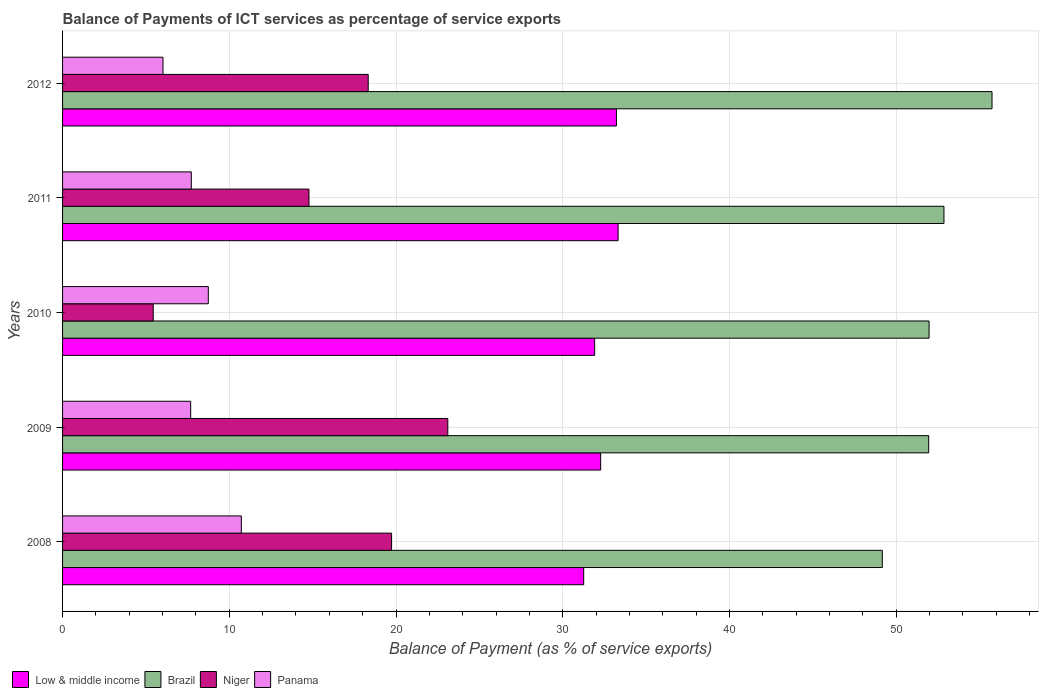How many different coloured bars are there?
Your answer should be very brief. 4. How many groups of bars are there?
Your answer should be compact. 5. Are the number of bars on each tick of the Y-axis equal?
Provide a short and direct response. Yes. What is the label of the 3rd group of bars from the top?
Make the answer very short. 2010. What is the balance of payments of ICT services in Panama in 2010?
Provide a succinct answer. 8.74. Across all years, what is the maximum balance of payments of ICT services in Niger?
Offer a very short reply. 23.11. Across all years, what is the minimum balance of payments of ICT services in Niger?
Your answer should be very brief. 5.44. What is the total balance of payments of ICT services in Panama in the graph?
Your response must be concise. 40.89. What is the difference between the balance of payments of ICT services in Low & middle income in 2008 and that in 2011?
Offer a terse response. -2.06. What is the difference between the balance of payments of ICT services in Low & middle income in 2008 and the balance of payments of ICT services in Brazil in 2012?
Your response must be concise. -24.49. What is the average balance of payments of ICT services in Low & middle income per year?
Your response must be concise. 32.4. In the year 2010, what is the difference between the balance of payments of ICT services in Low & middle income and balance of payments of ICT services in Panama?
Offer a very short reply. 23.17. In how many years, is the balance of payments of ICT services in Panama greater than 16 %?
Your answer should be compact. 0. What is the ratio of the balance of payments of ICT services in Panama in 2009 to that in 2010?
Ensure brevity in your answer.  0.88. Is the balance of payments of ICT services in Brazil in 2008 less than that in 2010?
Offer a very short reply. Yes. Is the difference between the balance of payments of ICT services in Low & middle income in 2008 and 2011 greater than the difference between the balance of payments of ICT services in Panama in 2008 and 2011?
Keep it short and to the point. No. What is the difference between the highest and the second highest balance of payments of ICT services in Brazil?
Ensure brevity in your answer.  2.88. What is the difference between the highest and the lowest balance of payments of ICT services in Niger?
Provide a succinct answer. 17.67. In how many years, is the balance of payments of ICT services in Low & middle income greater than the average balance of payments of ICT services in Low & middle income taken over all years?
Make the answer very short. 2. Is the sum of the balance of payments of ICT services in Niger in 2008 and 2010 greater than the maximum balance of payments of ICT services in Brazil across all years?
Your answer should be compact. No. Is it the case that in every year, the sum of the balance of payments of ICT services in Low & middle income and balance of payments of ICT services in Panama is greater than the sum of balance of payments of ICT services in Niger and balance of payments of ICT services in Brazil?
Ensure brevity in your answer.  Yes. What does the 1st bar from the top in 2008 represents?
Provide a short and direct response. Panama. What does the 2nd bar from the bottom in 2010 represents?
Ensure brevity in your answer.  Brazil. Is it the case that in every year, the sum of the balance of payments of ICT services in Niger and balance of payments of ICT services in Panama is greater than the balance of payments of ICT services in Low & middle income?
Ensure brevity in your answer.  No. Are all the bars in the graph horizontal?
Offer a terse response. Yes. How many years are there in the graph?
Give a very brief answer. 5. Are the values on the major ticks of X-axis written in scientific E-notation?
Your answer should be compact. No. Does the graph contain any zero values?
Your response must be concise. No. Where does the legend appear in the graph?
Keep it short and to the point. Bottom left. What is the title of the graph?
Ensure brevity in your answer.  Balance of Payments of ICT services as percentage of service exports. Does "Puerto Rico" appear as one of the legend labels in the graph?
Offer a terse response. No. What is the label or title of the X-axis?
Your response must be concise. Balance of Payment (as % of service exports). What is the Balance of Payment (as % of service exports) of Low & middle income in 2008?
Offer a terse response. 31.26. What is the Balance of Payment (as % of service exports) of Brazil in 2008?
Provide a succinct answer. 49.17. What is the Balance of Payment (as % of service exports) in Niger in 2008?
Your answer should be compact. 19.73. What is the Balance of Payment (as % of service exports) of Panama in 2008?
Offer a very short reply. 10.72. What is the Balance of Payment (as % of service exports) in Low & middle income in 2009?
Your answer should be very brief. 32.27. What is the Balance of Payment (as % of service exports) of Brazil in 2009?
Your answer should be very brief. 51.95. What is the Balance of Payment (as % of service exports) in Niger in 2009?
Provide a succinct answer. 23.11. What is the Balance of Payment (as % of service exports) in Panama in 2009?
Make the answer very short. 7.68. What is the Balance of Payment (as % of service exports) of Low & middle income in 2010?
Your answer should be compact. 31.91. What is the Balance of Payment (as % of service exports) in Brazil in 2010?
Offer a very short reply. 51.97. What is the Balance of Payment (as % of service exports) of Niger in 2010?
Ensure brevity in your answer.  5.44. What is the Balance of Payment (as % of service exports) in Panama in 2010?
Offer a very short reply. 8.74. What is the Balance of Payment (as % of service exports) of Low & middle income in 2011?
Your answer should be compact. 33.32. What is the Balance of Payment (as % of service exports) of Brazil in 2011?
Provide a succinct answer. 52.86. What is the Balance of Payment (as % of service exports) in Niger in 2011?
Give a very brief answer. 14.78. What is the Balance of Payment (as % of service exports) of Panama in 2011?
Provide a short and direct response. 7.72. What is the Balance of Payment (as % of service exports) of Low & middle income in 2012?
Provide a succinct answer. 33.22. What is the Balance of Payment (as % of service exports) of Brazil in 2012?
Ensure brevity in your answer.  55.75. What is the Balance of Payment (as % of service exports) in Niger in 2012?
Offer a very short reply. 18.33. What is the Balance of Payment (as % of service exports) in Panama in 2012?
Offer a terse response. 6.02. Across all years, what is the maximum Balance of Payment (as % of service exports) in Low & middle income?
Your answer should be very brief. 33.32. Across all years, what is the maximum Balance of Payment (as % of service exports) in Brazil?
Provide a short and direct response. 55.75. Across all years, what is the maximum Balance of Payment (as % of service exports) of Niger?
Your response must be concise. 23.11. Across all years, what is the maximum Balance of Payment (as % of service exports) of Panama?
Provide a short and direct response. 10.72. Across all years, what is the minimum Balance of Payment (as % of service exports) in Low & middle income?
Make the answer very short. 31.26. Across all years, what is the minimum Balance of Payment (as % of service exports) of Brazil?
Your response must be concise. 49.17. Across all years, what is the minimum Balance of Payment (as % of service exports) of Niger?
Provide a short and direct response. 5.44. Across all years, what is the minimum Balance of Payment (as % of service exports) of Panama?
Offer a very short reply. 6.02. What is the total Balance of Payment (as % of service exports) in Low & middle income in the graph?
Your answer should be compact. 161.98. What is the total Balance of Payment (as % of service exports) in Brazil in the graph?
Keep it short and to the point. 261.7. What is the total Balance of Payment (as % of service exports) in Niger in the graph?
Offer a terse response. 81.39. What is the total Balance of Payment (as % of service exports) of Panama in the graph?
Provide a succinct answer. 40.89. What is the difference between the Balance of Payment (as % of service exports) of Low & middle income in 2008 and that in 2009?
Your answer should be compact. -1.02. What is the difference between the Balance of Payment (as % of service exports) in Brazil in 2008 and that in 2009?
Offer a very short reply. -2.78. What is the difference between the Balance of Payment (as % of service exports) in Niger in 2008 and that in 2009?
Keep it short and to the point. -3.37. What is the difference between the Balance of Payment (as % of service exports) in Panama in 2008 and that in 2009?
Your answer should be very brief. 3.04. What is the difference between the Balance of Payment (as % of service exports) in Low & middle income in 2008 and that in 2010?
Your answer should be compact. -0.66. What is the difference between the Balance of Payment (as % of service exports) in Brazil in 2008 and that in 2010?
Provide a succinct answer. -2.81. What is the difference between the Balance of Payment (as % of service exports) of Niger in 2008 and that in 2010?
Provide a short and direct response. 14.3. What is the difference between the Balance of Payment (as % of service exports) of Panama in 2008 and that in 2010?
Your answer should be very brief. 1.98. What is the difference between the Balance of Payment (as % of service exports) of Low & middle income in 2008 and that in 2011?
Keep it short and to the point. -2.06. What is the difference between the Balance of Payment (as % of service exports) of Brazil in 2008 and that in 2011?
Provide a short and direct response. -3.7. What is the difference between the Balance of Payment (as % of service exports) in Niger in 2008 and that in 2011?
Offer a terse response. 4.95. What is the difference between the Balance of Payment (as % of service exports) in Panama in 2008 and that in 2011?
Your answer should be very brief. 3. What is the difference between the Balance of Payment (as % of service exports) in Low & middle income in 2008 and that in 2012?
Keep it short and to the point. -1.96. What is the difference between the Balance of Payment (as % of service exports) of Brazil in 2008 and that in 2012?
Offer a terse response. -6.58. What is the difference between the Balance of Payment (as % of service exports) in Niger in 2008 and that in 2012?
Your answer should be compact. 1.4. What is the difference between the Balance of Payment (as % of service exports) in Panama in 2008 and that in 2012?
Your response must be concise. 4.7. What is the difference between the Balance of Payment (as % of service exports) of Low & middle income in 2009 and that in 2010?
Keep it short and to the point. 0.36. What is the difference between the Balance of Payment (as % of service exports) of Brazil in 2009 and that in 2010?
Provide a short and direct response. -0.02. What is the difference between the Balance of Payment (as % of service exports) in Niger in 2009 and that in 2010?
Your answer should be very brief. 17.67. What is the difference between the Balance of Payment (as % of service exports) of Panama in 2009 and that in 2010?
Ensure brevity in your answer.  -1.06. What is the difference between the Balance of Payment (as % of service exports) in Low & middle income in 2009 and that in 2011?
Your answer should be very brief. -1.05. What is the difference between the Balance of Payment (as % of service exports) of Brazil in 2009 and that in 2011?
Offer a terse response. -0.92. What is the difference between the Balance of Payment (as % of service exports) in Niger in 2009 and that in 2011?
Keep it short and to the point. 8.33. What is the difference between the Balance of Payment (as % of service exports) in Panama in 2009 and that in 2011?
Keep it short and to the point. -0.04. What is the difference between the Balance of Payment (as % of service exports) in Low & middle income in 2009 and that in 2012?
Provide a succinct answer. -0.95. What is the difference between the Balance of Payment (as % of service exports) of Brazil in 2009 and that in 2012?
Your response must be concise. -3.8. What is the difference between the Balance of Payment (as % of service exports) of Niger in 2009 and that in 2012?
Make the answer very short. 4.78. What is the difference between the Balance of Payment (as % of service exports) of Panama in 2009 and that in 2012?
Your answer should be very brief. 1.66. What is the difference between the Balance of Payment (as % of service exports) of Low & middle income in 2010 and that in 2011?
Keep it short and to the point. -1.41. What is the difference between the Balance of Payment (as % of service exports) in Brazil in 2010 and that in 2011?
Keep it short and to the point. -0.89. What is the difference between the Balance of Payment (as % of service exports) of Niger in 2010 and that in 2011?
Provide a succinct answer. -9.34. What is the difference between the Balance of Payment (as % of service exports) of Panama in 2010 and that in 2011?
Give a very brief answer. 1.02. What is the difference between the Balance of Payment (as % of service exports) of Low & middle income in 2010 and that in 2012?
Keep it short and to the point. -1.31. What is the difference between the Balance of Payment (as % of service exports) of Brazil in 2010 and that in 2012?
Provide a succinct answer. -3.77. What is the difference between the Balance of Payment (as % of service exports) of Niger in 2010 and that in 2012?
Offer a terse response. -12.89. What is the difference between the Balance of Payment (as % of service exports) in Panama in 2010 and that in 2012?
Keep it short and to the point. 2.72. What is the difference between the Balance of Payment (as % of service exports) of Low & middle income in 2011 and that in 2012?
Your answer should be compact. 0.1. What is the difference between the Balance of Payment (as % of service exports) in Brazil in 2011 and that in 2012?
Give a very brief answer. -2.88. What is the difference between the Balance of Payment (as % of service exports) in Niger in 2011 and that in 2012?
Offer a terse response. -3.55. What is the difference between the Balance of Payment (as % of service exports) in Panama in 2011 and that in 2012?
Your response must be concise. 1.7. What is the difference between the Balance of Payment (as % of service exports) in Low & middle income in 2008 and the Balance of Payment (as % of service exports) in Brazil in 2009?
Your response must be concise. -20.69. What is the difference between the Balance of Payment (as % of service exports) of Low & middle income in 2008 and the Balance of Payment (as % of service exports) of Niger in 2009?
Ensure brevity in your answer.  8.15. What is the difference between the Balance of Payment (as % of service exports) of Low & middle income in 2008 and the Balance of Payment (as % of service exports) of Panama in 2009?
Provide a succinct answer. 23.57. What is the difference between the Balance of Payment (as % of service exports) of Brazil in 2008 and the Balance of Payment (as % of service exports) of Niger in 2009?
Offer a very short reply. 26.06. What is the difference between the Balance of Payment (as % of service exports) in Brazil in 2008 and the Balance of Payment (as % of service exports) in Panama in 2009?
Provide a short and direct response. 41.48. What is the difference between the Balance of Payment (as % of service exports) in Niger in 2008 and the Balance of Payment (as % of service exports) in Panama in 2009?
Your answer should be very brief. 12.05. What is the difference between the Balance of Payment (as % of service exports) of Low & middle income in 2008 and the Balance of Payment (as % of service exports) of Brazil in 2010?
Your response must be concise. -20.72. What is the difference between the Balance of Payment (as % of service exports) in Low & middle income in 2008 and the Balance of Payment (as % of service exports) in Niger in 2010?
Your answer should be compact. 25.82. What is the difference between the Balance of Payment (as % of service exports) in Low & middle income in 2008 and the Balance of Payment (as % of service exports) in Panama in 2010?
Provide a succinct answer. 22.51. What is the difference between the Balance of Payment (as % of service exports) in Brazil in 2008 and the Balance of Payment (as % of service exports) in Niger in 2010?
Provide a succinct answer. 43.73. What is the difference between the Balance of Payment (as % of service exports) in Brazil in 2008 and the Balance of Payment (as % of service exports) in Panama in 2010?
Your response must be concise. 40.43. What is the difference between the Balance of Payment (as % of service exports) in Niger in 2008 and the Balance of Payment (as % of service exports) in Panama in 2010?
Provide a short and direct response. 10.99. What is the difference between the Balance of Payment (as % of service exports) in Low & middle income in 2008 and the Balance of Payment (as % of service exports) in Brazil in 2011?
Make the answer very short. -21.61. What is the difference between the Balance of Payment (as % of service exports) in Low & middle income in 2008 and the Balance of Payment (as % of service exports) in Niger in 2011?
Give a very brief answer. 16.48. What is the difference between the Balance of Payment (as % of service exports) in Low & middle income in 2008 and the Balance of Payment (as % of service exports) in Panama in 2011?
Offer a terse response. 23.53. What is the difference between the Balance of Payment (as % of service exports) of Brazil in 2008 and the Balance of Payment (as % of service exports) of Niger in 2011?
Ensure brevity in your answer.  34.39. What is the difference between the Balance of Payment (as % of service exports) in Brazil in 2008 and the Balance of Payment (as % of service exports) in Panama in 2011?
Provide a short and direct response. 41.45. What is the difference between the Balance of Payment (as % of service exports) in Niger in 2008 and the Balance of Payment (as % of service exports) in Panama in 2011?
Offer a terse response. 12.01. What is the difference between the Balance of Payment (as % of service exports) of Low & middle income in 2008 and the Balance of Payment (as % of service exports) of Brazil in 2012?
Your response must be concise. -24.49. What is the difference between the Balance of Payment (as % of service exports) of Low & middle income in 2008 and the Balance of Payment (as % of service exports) of Niger in 2012?
Offer a very short reply. 12.92. What is the difference between the Balance of Payment (as % of service exports) of Low & middle income in 2008 and the Balance of Payment (as % of service exports) of Panama in 2012?
Keep it short and to the point. 25.23. What is the difference between the Balance of Payment (as % of service exports) of Brazil in 2008 and the Balance of Payment (as % of service exports) of Niger in 2012?
Offer a terse response. 30.84. What is the difference between the Balance of Payment (as % of service exports) of Brazil in 2008 and the Balance of Payment (as % of service exports) of Panama in 2012?
Provide a short and direct response. 43.14. What is the difference between the Balance of Payment (as % of service exports) of Niger in 2008 and the Balance of Payment (as % of service exports) of Panama in 2012?
Your answer should be compact. 13.71. What is the difference between the Balance of Payment (as % of service exports) of Low & middle income in 2009 and the Balance of Payment (as % of service exports) of Brazil in 2010?
Give a very brief answer. -19.7. What is the difference between the Balance of Payment (as % of service exports) in Low & middle income in 2009 and the Balance of Payment (as % of service exports) in Niger in 2010?
Ensure brevity in your answer.  26.84. What is the difference between the Balance of Payment (as % of service exports) of Low & middle income in 2009 and the Balance of Payment (as % of service exports) of Panama in 2010?
Keep it short and to the point. 23.53. What is the difference between the Balance of Payment (as % of service exports) in Brazil in 2009 and the Balance of Payment (as % of service exports) in Niger in 2010?
Your response must be concise. 46.51. What is the difference between the Balance of Payment (as % of service exports) in Brazil in 2009 and the Balance of Payment (as % of service exports) in Panama in 2010?
Ensure brevity in your answer.  43.21. What is the difference between the Balance of Payment (as % of service exports) in Niger in 2009 and the Balance of Payment (as % of service exports) in Panama in 2010?
Ensure brevity in your answer.  14.36. What is the difference between the Balance of Payment (as % of service exports) of Low & middle income in 2009 and the Balance of Payment (as % of service exports) of Brazil in 2011?
Offer a terse response. -20.59. What is the difference between the Balance of Payment (as % of service exports) of Low & middle income in 2009 and the Balance of Payment (as % of service exports) of Niger in 2011?
Make the answer very short. 17.49. What is the difference between the Balance of Payment (as % of service exports) of Low & middle income in 2009 and the Balance of Payment (as % of service exports) of Panama in 2011?
Offer a terse response. 24.55. What is the difference between the Balance of Payment (as % of service exports) in Brazil in 2009 and the Balance of Payment (as % of service exports) in Niger in 2011?
Your response must be concise. 37.17. What is the difference between the Balance of Payment (as % of service exports) of Brazil in 2009 and the Balance of Payment (as % of service exports) of Panama in 2011?
Give a very brief answer. 44.23. What is the difference between the Balance of Payment (as % of service exports) in Niger in 2009 and the Balance of Payment (as % of service exports) in Panama in 2011?
Make the answer very short. 15.38. What is the difference between the Balance of Payment (as % of service exports) of Low & middle income in 2009 and the Balance of Payment (as % of service exports) of Brazil in 2012?
Ensure brevity in your answer.  -23.47. What is the difference between the Balance of Payment (as % of service exports) in Low & middle income in 2009 and the Balance of Payment (as % of service exports) in Niger in 2012?
Ensure brevity in your answer.  13.94. What is the difference between the Balance of Payment (as % of service exports) of Low & middle income in 2009 and the Balance of Payment (as % of service exports) of Panama in 2012?
Your response must be concise. 26.25. What is the difference between the Balance of Payment (as % of service exports) in Brazil in 2009 and the Balance of Payment (as % of service exports) in Niger in 2012?
Make the answer very short. 33.62. What is the difference between the Balance of Payment (as % of service exports) of Brazil in 2009 and the Balance of Payment (as % of service exports) of Panama in 2012?
Ensure brevity in your answer.  45.93. What is the difference between the Balance of Payment (as % of service exports) in Niger in 2009 and the Balance of Payment (as % of service exports) in Panama in 2012?
Provide a short and direct response. 17.08. What is the difference between the Balance of Payment (as % of service exports) of Low & middle income in 2010 and the Balance of Payment (as % of service exports) of Brazil in 2011?
Offer a very short reply. -20.95. What is the difference between the Balance of Payment (as % of service exports) of Low & middle income in 2010 and the Balance of Payment (as % of service exports) of Niger in 2011?
Offer a very short reply. 17.13. What is the difference between the Balance of Payment (as % of service exports) in Low & middle income in 2010 and the Balance of Payment (as % of service exports) in Panama in 2011?
Give a very brief answer. 24.19. What is the difference between the Balance of Payment (as % of service exports) of Brazil in 2010 and the Balance of Payment (as % of service exports) of Niger in 2011?
Your answer should be compact. 37.19. What is the difference between the Balance of Payment (as % of service exports) of Brazil in 2010 and the Balance of Payment (as % of service exports) of Panama in 2011?
Offer a terse response. 44.25. What is the difference between the Balance of Payment (as % of service exports) of Niger in 2010 and the Balance of Payment (as % of service exports) of Panama in 2011?
Offer a very short reply. -2.28. What is the difference between the Balance of Payment (as % of service exports) of Low & middle income in 2010 and the Balance of Payment (as % of service exports) of Brazil in 2012?
Provide a succinct answer. -23.83. What is the difference between the Balance of Payment (as % of service exports) of Low & middle income in 2010 and the Balance of Payment (as % of service exports) of Niger in 2012?
Provide a succinct answer. 13.58. What is the difference between the Balance of Payment (as % of service exports) in Low & middle income in 2010 and the Balance of Payment (as % of service exports) in Panama in 2012?
Give a very brief answer. 25.89. What is the difference between the Balance of Payment (as % of service exports) of Brazil in 2010 and the Balance of Payment (as % of service exports) of Niger in 2012?
Offer a very short reply. 33.64. What is the difference between the Balance of Payment (as % of service exports) in Brazil in 2010 and the Balance of Payment (as % of service exports) in Panama in 2012?
Give a very brief answer. 45.95. What is the difference between the Balance of Payment (as % of service exports) of Niger in 2010 and the Balance of Payment (as % of service exports) of Panama in 2012?
Provide a succinct answer. -0.59. What is the difference between the Balance of Payment (as % of service exports) of Low & middle income in 2011 and the Balance of Payment (as % of service exports) of Brazil in 2012?
Offer a terse response. -22.43. What is the difference between the Balance of Payment (as % of service exports) of Low & middle income in 2011 and the Balance of Payment (as % of service exports) of Niger in 2012?
Provide a succinct answer. 14.99. What is the difference between the Balance of Payment (as % of service exports) of Low & middle income in 2011 and the Balance of Payment (as % of service exports) of Panama in 2012?
Make the answer very short. 27.3. What is the difference between the Balance of Payment (as % of service exports) of Brazil in 2011 and the Balance of Payment (as % of service exports) of Niger in 2012?
Provide a succinct answer. 34.53. What is the difference between the Balance of Payment (as % of service exports) of Brazil in 2011 and the Balance of Payment (as % of service exports) of Panama in 2012?
Keep it short and to the point. 46.84. What is the difference between the Balance of Payment (as % of service exports) of Niger in 2011 and the Balance of Payment (as % of service exports) of Panama in 2012?
Ensure brevity in your answer.  8.76. What is the average Balance of Payment (as % of service exports) of Low & middle income per year?
Offer a very short reply. 32.4. What is the average Balance of Payment (as % of service exports) of Brazil per year?
Provide a succinct answer. 52.34. What is the average Balance of Payment (as % of service exports) of Niger per year?
Your response must be concise. 16.28. What is the average Balance of Payment (as % of service exports) in Panama per year?
Your answer should be compact. 8.18. In the year 2008, what is the difference between the Balance of Payment (as % of service exports) in Low & middle income and Balance of Payment (as % of service exports) in Brazil?
Offer a very short reply. -17.91. In the year 2008, what is the difference between the Balance of Payment (as % of service exports) in Low & middle income and Balance of Payment (as % of service exports) in Niger?
Make the answer very short. 11.52. In the year 2008, what is the difference between the Balance of Payment (as % of service exports) in Low & middle income and Balance of Payment (as % of service exports) in Panama?
Your answer should be compact. 20.53. In the year 2008, what is the difference between the Balance of Payment (as % of service exports) in Brazil and Balance of Payment (as % of service exports) in Niger?
Keep it short and to the point. 29.43. In the year 2008, what is the difference between the Balance of Payment (as % of service exports) in Brazil and Balance of Payment (as % of service exports) in Panama?
Ensure brevity in your answer.  38.44. In the year 2008, what is the difference between the Balance of Payment (as % of service exports) of Niger and Balance of Payment (as % of service exports) of Panama?
Provide a short and direct response. 9.01. In the year 2009, what is the difference between the Balance of Payment (as % of service exports) in Low & middle income and Balance of Payment (as % of service exports) in Brazil?
Offer a very short reply. -19.68. In the year 2009, what is the difference between the Balance of Payment (as % of service exports) in Low & middle income and Balance of Payment (as % of service exports) in Niger?
Provide a succinct answer. 9.17. In the year 2009, what is the difference between the Balance of Payment (as % of service exports) of Low & middle income and Balance of Payment (as % of service exports) of Panama?
Your response must be concise. 24.59. In the year 2009, what is the difference between the Balance of Payment (as % of service exports) of Brazil and Balance of Payment (as % of service exports) of Niger?
Keep it short and to the point. 28.84. In the year 2009, what is the difference between the Balance of Payment (as % of service exports) in Brazil and Balance of Payment (as % of service exports) in Panama?
Offer a very short reply. 44.27. In the year 2009, what is the difference between the Balance of Payment (as % of service exports) in Niger and Balance of Payment (as % of service exports) in Panama?
Give a very brief answer. 15.42. In the year 2010, what is the difference between the Balance of Payment (as % of service exports) of Low & middle income and Balance of Payment (as % of service exports) of Brazil?
Offer a very short reply. -20.06. In the year 2010, what is the difference between the Balance of Payment (as % of service exports) of Low & middle income and Balance of Payment (as % of service exports) of Niger?
Make the answer very short. 26.47. In the year 2010, what is the difference between the Balance of Payment (as % of service exports) of Low & middle income and Balance of Payment (as % of service exports) of Panama?
Offer a terse response. 23.17. In the year 2010, what is the difference between the Balance of Payment (as % of service exports) of Brazil and Balance of Payment (as % of service exports) of Niger?
Provide a short and direct response. 46.53. In the year 2010, what is the difference between the Balance of Payment (as % of service exports) in Brazil and Balance of Payment (as % of service exports) in Panama?
Give a very brief answer. 43.23. In the year 2010, what is the difference between the Balance of Payment (as % of service exports) of Niger and Balance of Payment (as % of service exports) of Panama?
Provide a short and direct response. -3.3. In the year 2011, what is the difference between the Balance of Payment (as % of service exports) of Low & middle income and Balance of Payment (as % of service exports) of Brazil?
Give a very brief answer. -19.54. In the year 2011, what is the difference between the Balance of Payment (as % of service exports) in Low & middle income and Balance of Payment (as % of service exports) in Niger?
Your answer should be very brief. 18.54. In the year 2011, what is the difference between the Balance of Payment (as % of service exports) of Low & middle income and Balance of Payment (as % of service exports) of Panama?
Ensure brevity in your answer.  25.6. In the year 2011, what is the difference between the Balance of Payment (as % of service exports) in Brazil and Balance of Payment (as % of service exports) in Niger?
Offer a very short reply. 38.09. In the year 2011, what is the difference between the Balance of Payment (as % of service exports) in Brazil and Balance of Payment (as % of service exports) in Panama?
Ensure brevity in your answer.  45.14. In the year 2011, what is the difference between the Balance of Payment (as % of service exports) in Niger and Balance of Payment (as % of service exports) in Panama?
Your answer should be very brief. 7.06. In the year 2012, what is the difference between the Balance of Payment (as % of service exports) of Low & middle income and Balance of Payment (as % of service exports) of Brazil?
Make the answer very short. -22.53. In the year 2012, what is the difference between the Balance of Payment (as % of service exports) of Low & middle income and Balance of Payment (as % of service exports) of Niger?
Ensure brevity in your answer.  14.89. In the year 2012, what is the difference between the Balance of Payment (as % of service exports) in Low & middle income and Balance of Payment (as % of service exports) in Panama?
Give a very brief answer. 27.2. In the year 2012, what is the difference between the Balance of Payment (as % of service exports) in Brazil and Balance of Payment (as % of service exports) in Niger?
Offer a terse response. 37.42. In the year 2012, what is the difference between the Balance of Payment (as % of service exports) of Brazil and Balance of Payment (as % of service exports) of Panama?
Provide a succinct answer. 49.72. In the year 2012, what is the difference between the Balance of Payment (as % of service exports) in Niger and Balance of Payment (as % of service exports) in Panama?
Ensure brevity in your answer.  12.31. What is the ratio of the Balance of Payment (as % of service exports) of Low & middle income in 2008 to that in 2009?
Keep it short and to the point. 0.97. What is the ratio of the Balance of Payment (as % of service exports) in Brazil in 2008 to that in 2009?
Offer a terse response. 0.95. What is the ratio of the Balance of Payment (as % of service exports) of Niger in 2008 to that in 2009?
Keep it short and to the point. 0.85. What is the ratio of the Balance of Payment (as % of service exports) of Panama in 2008 to that in 2009?
Ensure brevity in your answer.  1.4. What is the ratio of the Balance of Payment (as % of service exports) in Low & middle income in 2008 to that in 2010?
Ensure brevity in your answer.  0.98. What is the ratio of the Balance of Payment (as % of service exports) in Brazil in 2008 to that in 2010?
Your answer should be compact. 0.95. What is the ratio of the Balance of Payment (as % of service exports) of Niger in 2008 to that in 2010?
Offer a very short reply. 3.63. What is the ratio of the Balance of Payment (as % of service exports) in Panama in 2008 to that in 2010?
Ensure brevity in your answer.  1.23. What is the ratio of the Balance of Payment (as % of service exports) of Low & middle income in 2008 to that in 2011?
Your answer should be compact. 0.94. What is the ratio of the Balance of Payment (as % of service exports) of Brazil in 2008 to that in 2011?
Your answer should be very brief. 0.93. What is the ratio of the Balance of Payment (as % of service exports) of Niger in 2008 to that in 2011?
Make the answer very short. 1.34. What is the ratio of the Balance of Payment (as % of service exports) of Panama in 2008 to that in 2011?
Provide a short and direct response. 1.39. What is the ratio of the Balance of Payment (as % of service exports) in Low & middle income in 2008 to that in 2012?
Offer a terse response. 0.94. What is the ratio of the Balance of Payment (as % of service exports) in Brazil in 2008 to that in 2012?
Offer a terse response. 0.88. What is the ratio of the Balance of Payment (as % of service exports) in Niger in 2008 to that in 2012?
Provide a short and direct response. 1.08. What is the ratio of the Balance of Payment (as % of service exports) in Panama in 2008 to that in 2012?
Your answer should be very brief. 1.78. What is the ratio of the Balance of Payment (as % of service exports) in Low & middle income in 2009 to that in 2010?
Provide a short and direct response. 1.01. What is the ratio of the Balance of Payment (as % of service exports) in Niger in 2009 to that in 2010?
Offer a very short reply. 4.25. What is the ratio of the Balance of Payment (as % of service exports) of Panama in 2009 to that in 2010?
Your response must be concise. 0.88. What is the ratio of the Balance of Payment (as % of service exports) in Low & middle income in 2009 to that in 2011?
Keep it short and to the point. 0.97. What is the ratio of the Balance of Payment (as % of service exports) in Brazil in 2009 to that in 2011?
Give a very brief answer. 0.98. What is the ratio of the Balance of Payment (as % of service exports) of Niger in 2009 to that in 2011?
Offer a terse response. 1.56. What is the ratio of the Balance of Payment (as % of service exports) in Panama in 2009 to that in 2011?
Your answer should be very brief. 1. What is the ratio of the Balance of Payment (as % of service exports) of Low & middle income in 2009 to that in 2012?
Your answer should be compact. 0.97. What is the ratio of the Balance of Payment (as % of service exports) in Brazil in 2009 to that in 2012?
Your answer should be compact. 0.93. What is the ratio of the Balance of Payment (as % of service exports) in Niger in 2009 to that in 2012?
Offer a terse response. 1.26. What is the ratio of the Balance of Payment (as % of service exports) of Panama in 2009 to that in 2012?
Ensure brevity in your answer.  1.28. What is the ratio of the Balance of Payment (as % of service exports) in Low & middle income in 2010 to that in 2011?
Your answer should be compact. 0.96. What is the ratio of the Balance of Payment (as % of service exports) in Brazil in 2010 to that in 2011?
Your answer should be compact. 0.98. What is the ratio of the Balance of Payment (as % of service exports) in Niger in 2010 to that in 2011?
Ensure brevity in your answer.  0.37. What is the ratio of the Balance of Payment (as % of service exports) of Panama in 2010 to that in 2011?
Offer a terse response. 1.13. What is the ratio of the Balance of Payment (as % of service exports) of Low & middle income in 2010 to that in 2012?
Offer a terse response. 0.96. What is the ratio of the Balance of Payment (as % of service exports) in Brazil in 2010 to that in 2012?
Ensure brevity in your answer.  0.93. What is the ratio of the Balance of Payment (as % of service exports) of Niger in 2010 to that in 2012?
Ensure brevity in your answer.  0.3. What is the ratio of the Balance of Payment (as % of service exports) in Panama in 2010 to that in 2012?
Ensure brevity in your answer.  1.45. What is the ratio of the Balance of Payment (as % of service exports) in Low & middle income in 2011 to that in 2012?
Offer a terse response. 1. What is the ratio of the Balance of Payment (as % of service exports) of Brazil in 2011 to that in 2012?
Offer a terse response. 0.95. What is the ratio of the Balance of Payment (as % of service exports) in Niger in 2011 to that in 2012?
Your answer should be very brief. 0.81. What is the ratio of the Balance of Payment (as % of service exports) in Panama in 2011 to that in 2012?
Ensure brevity in your answer.  1.28. What is the difference between the highest and the second highest Balance of Payment (as % of service exports) of Low & middle income?
Your response must be concise. 0.1. What is the difference between the highest and the second highest Balance of Payment (as % of service exports) of Brazil?
Keep it short and to the point. 2.88. What is the difference between the highest and the second highest Balance of Payment (as % of service exports) of Niger?
Give a very brief answer. 3.37. What is the difference between the highest and the second highest Balance of Payment (as % of service exports) of Panama?
Ensure brevity in your answer.  1.98. What is the difference between the highest and the lowest Balance of Payment (as % of service exports) in Low & middle income?
Keep it short and to the point. 2.06. What is the difference between the highest and the lowest Balance of Payment (as % of service exports) of Brazil?
Give a very brief answer. 6.58. What is the difference between the highest and the lowest Balance of Payment (as % of service exports) in Niger?
Your answer should be compact. 17.67. What is the difference between the highest and the lowest Balance of Payment (as % of service exports) in Panama?
Give a very brief answer. 4.7. 